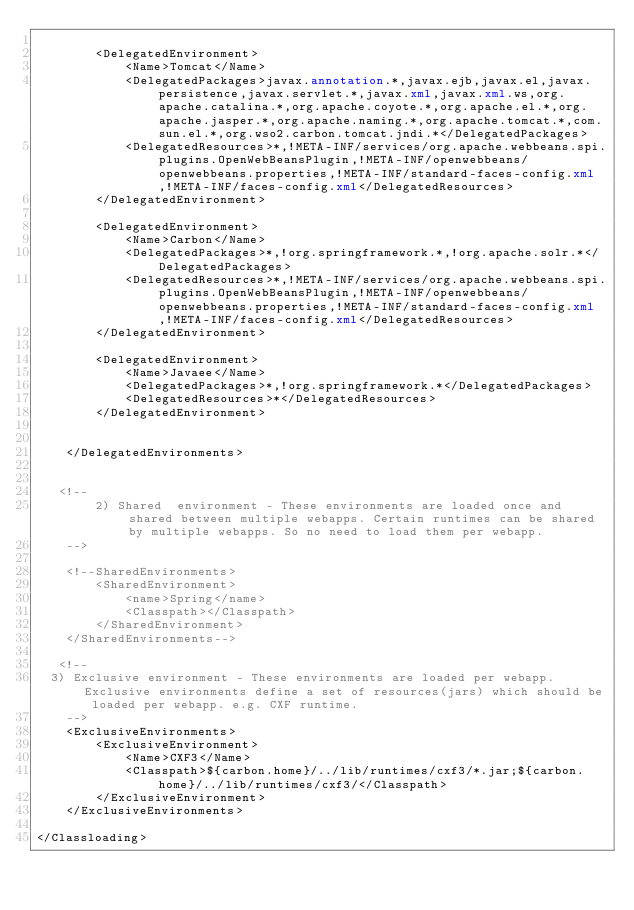Convert code to text. <code><loc_0><loc_0><loc_500><loc_500><_XML_>
        <DelegatedEnvironment>
            <Name>Tomcat</Name>
            <DelegatedPackages>javax.annotation.*,javax.ejb,javax.el,javax.persistence,javax.servlet.*,javax.xml,javax.xml.ws,org.apache.catalina.*,org.apache.coyote.*,org.apache.el.*,org.apache.jasper.*,org.apache.naming.*,org.apache.tomcat.*,com.sun.el.*,org.wso2.carbon.tomcat.jndi.*</DelegatedPackages>
            <DelegatedResources>*,!META-INF/services/org.apache.webbeans.spi.plugins.OpenWebBeansPlugin,!META-INF/openwebbeans/openwebbeans.properties,!META-INF/standard-faces-config.xml,!META-INF/faces-config.xml</DelegatedResources>
        </DelegatedEnvironment>

        <DelegatedEnvironment>
            <Name>Carbon</Name>
            <DelegatedPackages>*,!org.springframework.*,!org.apache.solr.*</DelegatedPackages>
            <DelegatedResources>*,!META-INF/services/org.apache.webbeans.spi.plugins.OpenWebBeansPlugin,!META-INF/openwebbeans/openwebbeans.properties,!META-INF/standard-faces-config.xml,!META-INF/faces-config.xml</DelegatedResources>
        </DelegatedEnvironment>

        <DelegatedEnvironment>
            <Name>Javaee</Name>
            <DelegatedPackages>*,!org.springframework.*</DelegatedPackages>
            <DelegatedResources>*</DelegatedResources>
        </DelegatedEnvironment>


    </DelegatedEnvironments>


   <!-- 
        2) Shared  environment - These environments are loaded once and shared between multiple webapps. Certain runtimes can be shared by multiple webapps. So no need to load them per webapp.
    -->

    <!--SharedEnvironments>
        <SharedEnvironment>
            <name>Spring</name>
            <Classpath></Classpath>
        </SharedEnvironment>
    </SharedEnvironments-->

   <!-- 
	3) Exclusive environment - These environments are loaded per webapp. Exclusive environments define a set of resources(jars) which should be loaded per webapp. e.g. CXF runtime.
    -->	
    <ExclusiveEnvironments>
        <ExclusiveEnvironment>
            <Name>CXF3</Name>
            <Classpath>${carbon.home}/../lib/runtimes/cxf3/*.jar;${carbon.home}/../lib/runtimes/cxf3/</Classpath>
        </ExclusiveEnvironment>
    </ExclusiveEnvironments>

</Classloading>
</code> 